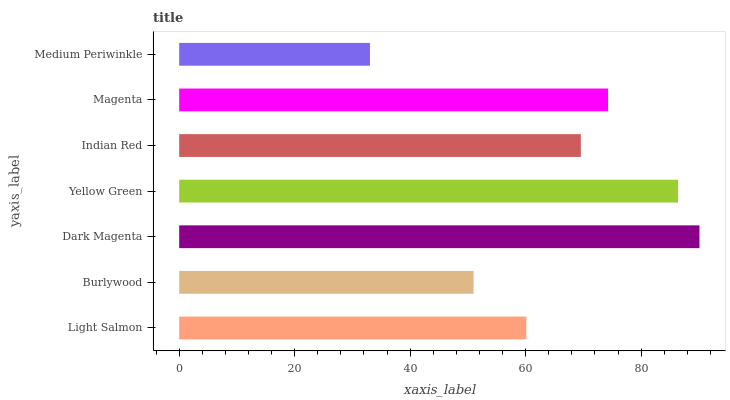Is Medium Periwinkle the minimum?
Answer yes or no. Yes. Is Dark Magenta the maximum?
Answer yes or no. Yes. Is Burlywood the minimum?
Answer yes or no. No. Is Burlywood the maximum?
Answer yes or no. No. Is Light Salmon greater than Burlywood?
Answer yes or no. Yes. Is Burlywood less than Light Salmon?
Answer yes or no. Yes. Is Burlywood greater than Light Salmon?
Answer yes or no. No. Is Light Salmon less than Burlywood?
Answer yes or no. No. Is Indian Red the high median?
Answer yes or no. Yes. Is Indian Red the low median?
Answer yes or no. Yes. Is Burlywood the high median?
Answer yes or no. No. Is Yellow Green the low median?
Answer yes or no. No. 